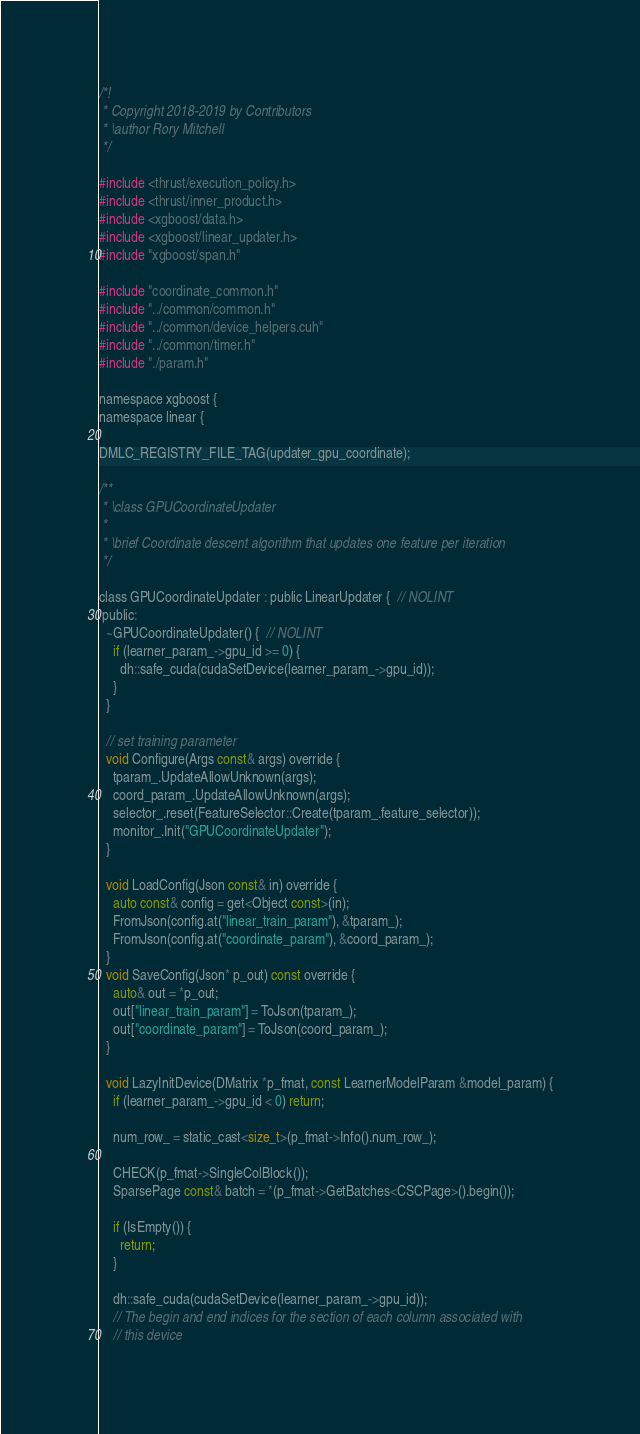<code> <loc_0><loc_0><loc_500><loc_500><_Cuda_>/*!
 * Copyright 2018-2019 by Contributors
 * \author Rory Mitchell
 */

#include <thrust/execution_policy.h>
#include <thrust/inner_product.h>
#include <xgboost/data.h>
#include <xgboost/linear_updater.h>
#include "xgboost/span.h"

#include "coordinate_common.h"
#include "../common/common.h"
#include "../common/device_helpers.cuh"
#include "../common/timer.h"
#include "./param.h"

namespace xgboost {
namespace linear {

DMLC_REGISTRY_FILE_TAG(updater_gpu_coordinate);

/**
 * \class GPUCoordinateUpdater
 *
 * \brief Coordinate descent algorithm that updates one feature per iteration
 */

class GPUCoordinateUpdater : public LinearUpdater {  // NOLINT
 public:
  ~GPUCoordinateUpdater() {  // NOLINT
    if (learner_param_->gpu_id >= 0) {
      dh::safe_cuda(cudaSetDevice(learner_param_->gpu_id));
    }
  }

  // set training parameter
  void Configure(Args const& args) override {
    tparam_.UpdateAllowUnknown(args);
    coord_param_.UpdateAllowUnknown(args);
    selector_.reset(FeatureSelector::Create(tparam_.feature_selector));
    monitor_.Init("GPUCoordinateUpdater");
  }

  void LoadConfig(Json const& in) override {
    auto const& config = get<Object const>(in);
    FromJson(config.at("linear_train_param"), &tparam_);
    FromJson(config.at("coordinate_param"), &coord_param_);
  }
  void SaveConfig(Json* p_out) const override {
    auto& out = *p_out;
    out["linear_train_param"] = ToJson(tparam_);
    out["coordinate_param"] = ToJson(coord_param_);
  }

  void LazyInitDevice(DMatrix *p_fmat, const LearnerModelParam &model_param) {
    if (learner_param_->gpu_id < 0) return;

    num_row_ = static_cast<size_t>(p_fmat->Info().num_row_);

    CHECK(p_fmat->SingleColBlock());
    SparsePage const& batch = *(p_fmat->GetBatches<CSCPage>().begin());

    if (IsEmpty()) {
      return;
    }

    dh::safe_cuda(cudaSetDevice(learner_param_->gpu_id));
    // The begin and end indices for the section of each column associated with
    // this device</code> 